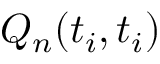<formula> <loc_0><loc_0><loc_500><loc_500>Q _ { n } ( t _ { i } , t _ { i } )</formula> 